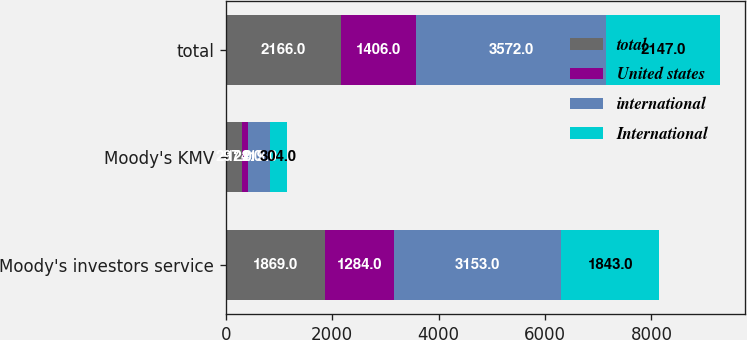<chart> <loc_0><loc_0><loc_500><loc_500><stacked_bar_chart><ecel><fcel>Moody's investors service<fcel>Moody's KMV<fcel>total<nl><fcel>total<fcel>1869<fcel>297<fcel>2166<nl><fcel>United states<fcel>1284<fcel>122<fcel>1406<nl><fcel>international<fcel>3153<fcel>419<fcel>3572<nl><fcel>International<fcel>1843<fcel>304<fcel>2147<nl></chart> 